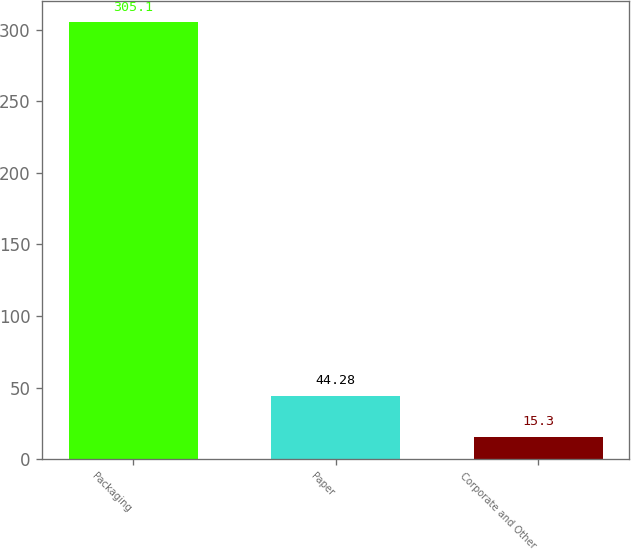Convert chart to OTSL. <chart><loc_0><loc_0><loc_500><loc_500><bar_chart><fcel>Packaging<fcel>Paper<fcel>Corporate and Other<nl><fcel>305.1<fcel>44.28<fcel>15.3<nl></chart> 